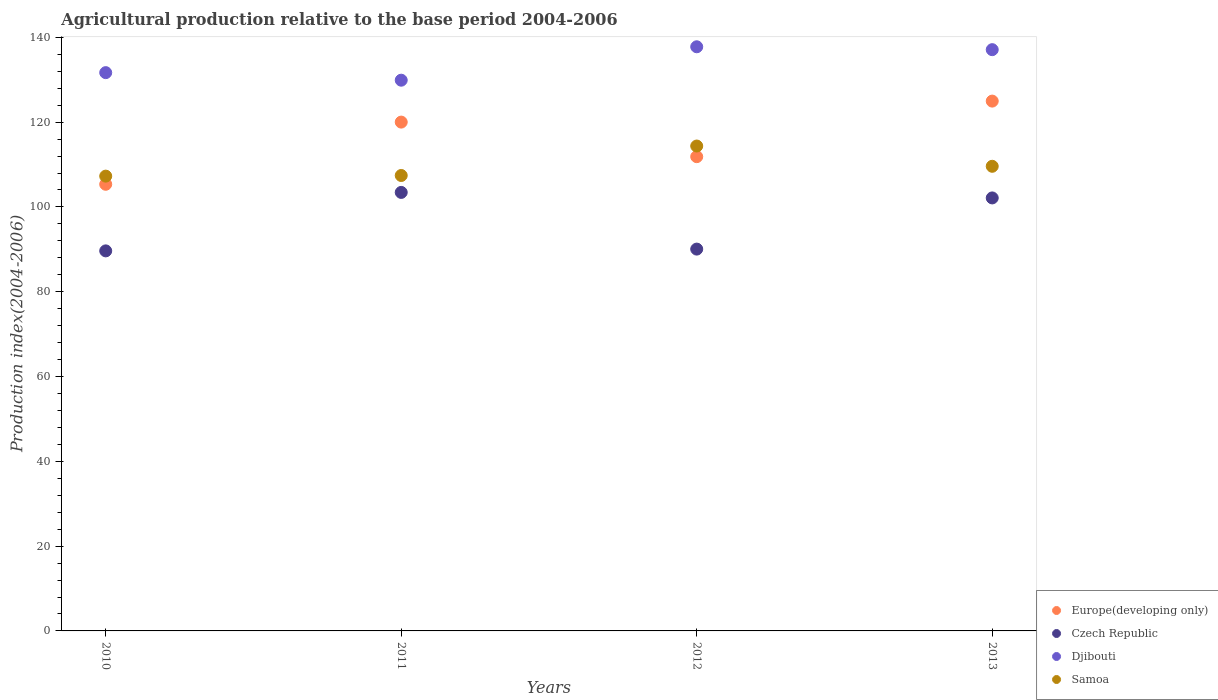Is the number of dotlines equal to the number of legend labels?
Your answer should be very brief. Yes. What is the agricultural production index in Samoa in 2011?
Provide a succinct answer. 107.42. Across all years, what is the maximum agricultural production index in Europe(developing only)?
Offer a very short reply. 124.97. Across all years, what is the minimum agricultural production index in Europe(developing only)?
Offer a terse response. 105.35. What is the total agricultural production index in Europe(developing only) in the graph?
Keep it short and to the point. 462.19. What is the difference between the agricultural production index in Djibouti in 2012 and that in 2013?
Your answer should be compact. 0.68. What is the difference between the agricultural production index in Djibouti in 2013 and the agricultural production index in Czech Republic in 2010?
Your response must be concise. 47.46. What is the average agricultural production index in Samoa per year?
Your answer should be very brief. 109.66. In the year 2012, what is the difference between the agricultural production index in Djibouti and agricultural production index in Europe(developing only)?
Make the answer very short. 25.92. In how many years, is the agricultural production index in Djibouti greater than 60?
Make the answer very short. 4. What is the ratio of the agricultural production index in Djibouti in 2010 to that in 2011?
Your answer should be very brief. 1.01. What is the difference between the highest and the second highest agricultural production index in Europe(developing only)?
Your answer should be compact. 4.95. What is the difference between the highest and the lowest agricultural production index in Samoa?
Offer a very short reply. 7.1. Is the agricultural production index in Czech Republic strictly greater than the agricultural production index in Djibouti over the years?
Provide a succinct answer. No. Is the agricultural production index in Samoa strictly less than the agricultural production index in Europe(developing only) over the years?
Your answer should be compact. No. What is the difference between two consecutive major ticks on the Y-axis?
Offer a terse response. 20. Are the values on the major ticks of Y-axis written in scientific E-notation?
Offer a very short reply. No. Does the graph contain any zero values?
Give a very brief answer. No. How many legend labels are there?
Provide a succinct answer. 4. What is the title of the graph?
Offer a terse response. Agricultural production relative to the base period 2004-2006. What is the label or title of the X-axis?
Give a very brief answer. Years. What is the label or title of the Y-axis?
Your response must be concise. Production index(2004-2006). What is the Production index(2004-2006) in Europe(developing only) in 2010?
Your answer should be very brief. 105.35. What is the Production index(2004-2006) in Czech Republic in 2010?
Make the answer very short. 89.64. What is the Production index(2004-2006) of Djibouti in 2010?
Make the answer very short. 131.68. What is the Production index(2004-2006) in Samoa in 2010?
Your answer should be compact. 107.27. What is the Production index(2004-2006) of Europe(developing only) in 2011?
Your response must be concise. 120.01. What is the Production index(2004-2006) of Czech Republic in 2011?
Your response must be concise. 103.43. What is the Production index(2004-2006) in Djibouti in 2011?
Provide a short and direct response. 129.9. What is the Production index(2004-2006) in Samoa in 2011?
Your answer should be compact. 107.42. What is the Production index(2004-2006) in Europe(developing only) in 2012?
Your answer should be very brief. 111.86. What is the Production index(2004-2006) of Czech Republic in 2012?
Offer a very short reply. 90.06. What is the Production index(2004-2006) in Djibouti in 2012?
Keep it short and to the point. 137.78. What is the Production index(2004-2006) in Samoa in 2012?
Keep it short and to the point. 114.37. What is the Production index(2004-2006) in Europe(developing only) in 2013?
Your response must be concise. 124.97. What is the Production index(2004-2006) in Czech Republic in 2013?
Your answer should be very brief. 102.13. What is the Production index(2004-2006) of Djibouti in 2013?
Offer a very short reply. 137.1. What is the Production index(2004-2006) in Samoa in 2013?
Provide a succinct answer. 109.59. Across all years, what is the maximum Production index(2004-2006) in Europe(developing only)?
Your answer should be compact. 124.97. Across all years, what is the maximum Production index(2004-2006) in Czech Republic?
Provide a succinct answer. 103.43. Across all years, what is the maximum Production index(2004-2006) of Djibouti?
Ensure brevity in your answer.  137.78. Across all years, what is the maximum Production index(2004-2006) of Samoa?
Ensure brevity in your answer.  114.37. Across all years, what is the minimum Production index(2004-2006) of Europe(developing only)?
Give a very brief answer. 105.35. Across all years, what is the minimum Production index(2004-2006) in Czech Republic?
Your answer should be very brief. 89.64. Across all years, what is the minimum Production index(2004-2006) of Djibouti?
Keep it short and to the point. 129.9. Across all years, what is the minimum Production index(2004-2006) of Samoa?
Provide a short and direct response. 107.27. What is the total Production index(2004-2006) in Europe(developing only) in the graph?
Ensure brevity in your answer.  462.19. What is the total Production index(2004-2006) in Czech Republic in the graph?
Your response must be concise. 385.26. What is the total Production index(2004-2006) in Djibouti in the graph?
Your response must be concise. 536.46. What is the total Production index(2004-2006) in Samoa in the graph?
Provide a succinct answer. 438.65. What is the difference between the Production index(2004-2006) in Europe(developing only) in 2010 and that in 2011?
Provide a short and direct response. -14.67. What is the difference between the Production index(2004-2006) of Czech Republic in 2010 and that in 2011?
Keep it short and to the point. -13.79. What is the difference between the Production index(2004-2006) in Djibouti in 2010 and that in 2011?
Your answer should be very brief. 1.78. What is the difference between the Production index(2004-2006) in Europe(developing only) in 2010 and that in 2012?
Your answer should be very brief. -6.51. What is the difference between the Production index(2004-2006) in Czech Republic in 2010 and that in 2012?
Your answer should be compact. -0.42. What is the difference between the Production index(2004-2006) in Samoa in 2010 and that in 2012?
Give a very brief answer. -7.1. What is the difference between the Production index(2004-2006) in Europe(developing only) in 2010 and that in 2013?
Make the answer very short. -19.62. What is the difference between the Production index(2004-2006) of Czech Republic in 2010 and that in 2013?
Your answer should be compact. -12.49. What is the difference between the Production index(2004-2006) in Djibouti in 2010 and that in 2013?
Ensure brevity in your answer.  -5.42. What is the difference between the Production index(2004-2006) of Samoa in 2010 and that in 2013?
Make the answer very short. -2.32. What is the difference between the Production index(2004-2006) in Europe(developing only) in 2011 and that in 2012?
Offer a terse response. 8.15. What is the difference between the Production index(2004-2006) in Czech Republic in 2011 and that in 2012?
Your answer should be very brief. 13.37. What is the difference between the Production index(2004-2006) in Djibouti in 2011 and that in 2012?
Make the answer very short. -7.88. What is the difference between the Production index(2004-2006) of Samoa in 2011 and that in 2012?
Offer a very short reply. -6.95. What is the difference between the Production index(2004-2006) in Europe(developing only) in 2011 and that in 2013?
Offer a terse response. -4.95. What is the difference between the Production index(2004-2006) in Samoa in 2011 and that in 2013?
Provide a succinct answer. -2.17. What is the difference between the Production index(2004-2006) in Europe(developing only) in 2012 and that in 2013?
Your answer should be compact. -13.1. What is the difference between the Production index(2004-2006) of Czech Republic in 2012 and that in 2013?
Provide a short and direct response. -12.07. What is the difference between the Production index(2004-2006) in Djibouti in 2012 and that in 2013?
Offer a terse response. 0.68. What is the difference between the Production index(2004-2006) of Samoa in 2012 and that in 2013?
Ensure brevity in your answer.  4.78. What is the difference between the Production index(2004-2006) of Europe(developing only) in 2010 and the Production index(2004-2006) of Czech Republic in 2011?
Your answer should be very brief. 1.92. What is the difference between the Production index(2004-2006) of Europe(developing only) in 2010 and the Production index(2004-2006) of Djibouti in 2011?
Your response must be concise. -24.55. What is the difference between the Production index(2004-2006) of Europe(developing only) in 2010 and the Production index(2004-2006) of Samoa in 2011?
Give a very brief answer. -2.07. What is the difference between the Production index(2004-2006) in Czech Republic in 2010 and the Production index(2004-2006) in Djibouti in 2011?
Keep it short and to the point. -40.26. What is the difference between the Production index(2004-2006) in Czech Republic in 2010 and the Production index(2004-2006) in Samoa in 2011?
Make the answer very short. -17.78. What is the difference between the Production index(2004-2006) of Djibouti in 2010 and the Production index(2004-2006) of Samoa in 2011?
Ensure brevity in your answer.  24.26. What is the difference between the Production index(2004-2006) of Europe(developing only) in 2010 and the Production index(2004-2006) of Czech Republic in 2012?
Your response must be concise. 15.29. What is the difference between the Production index(2004-2006) in Europe(developing only) in 2010 and the Production index(2004-2006) in Djibouti in 2012?
Give a very brief answer. -32.43. What is the difference between the Production index(2004-2006) in Europe(developing only) in 2010 and the Production index(2004-2006) in Samoa in 2012?
Offer a terse response. -9.02. What is the difference between the Production index(2004-2006) in Czech Republic in 2010 and the Production index(2004-2006) in Djibouti in 2012?
Offer a terse response. -48.14. What is the difference between the Production index(2004-2006) in Czech Republic in 2010 and the Production index(2004-2006) in Samoa in 2012?
Ensure brevity in your answer.  -24.73. What is the difference between the Production index(2004-2006) of Djibouti in 2010 and the Production index(2004-2006) of Samoa in 2012?
Your response must be concise. 17.31. What is the difference between the Production index(2004-2006) of Europe(developing only) in 2010 and the Production index(2004-2006) of Czech Republic in 2013?
Your answer should be compact. 3.22. What is the difference between the Production index(2004-2006) of Europe(developing only) in 2010 and the Production index(2004-2006) of Djibouti in 2013?
Offer a very short reply. -31.75. What is the difference between the Production index(2004-2006) in Europe(developing only) in 2010 and the Production index(2004-2006) in Samoa in 2013?
Make the answer very short. -4.24. What is the difference between the Production index(2004-2006) of Czech Republic in 2010 and the Production index(2004-2006) of Djibouti in 2013?
Ensure brevity in your answer.  -47.46. What is the difference between the Production index(2004-2006) of Czech Republic in 2010 and the Production index(2004-2006) of Samoa in 2013?
Ensure brevity in your answer.  -19.95. What is the difference between the Production index(2004-2006) in Djibouti in 2010 and the Production index(2004-2006) in Samoa in 2013?
Your response must be concise. 22.09. What is the difference between the Production index(2004-2006) in Europe(developing only) in 2011 and the Production index(2004-2006) in Czech Republic in 2012?
Your answer should be very brief. 29.95. What is the difference between the Production index(2004-2006) of Europe(developing only) in 2011 and the Production index(2004-2006) of Djibouti in 2012?
Your response must be concise. -17.77. What is the difference between the Production index(2004-2006) of Europe(developing only) in 2011 and the Production index(2004-2006) of Samoa in 2012?
Make the answer very short. 5.64. What is the difference between the Production index(2004-2006) in Czech Republic in 2011 and the Production index(2004-2006) in Djibouti in 2012?
Ensure brevity in your answer.  -34.35. What is the difference between the Production index(2004-2006) in Czech Republic in 2011 and the Production index(2004-2006) in Samoa in 2012?
Your response must be concise. -10.94. What is the difference between the Production index(2004-2006) of Djibouti in 2011 and the Production index(2004-2006) of Samoa in 2012?
Ensure brevity in your answer.  15.53. What is the difference between the Production index(2004-2006) of Europe(developing only) in 2011 and the Production index(2004-2006) of Czech Republic in 2013?
Make the answer very short. 17.88. What is the difference between the Production index(2004-2006) in Europe(developing only) in 2011 and the Production index(2004-2006) in Djibouti in 2013?
Provide a succinct answer. -17.09. What is the difference between the Production index(2004-2006) of Europe(developing only) in 2011 and the Production index(2004-2006) of Samoa in 2013?
Provide a succinct answer. 10.42. What is the difference between the Production index(2004-2006) of Czech Republic in 2011 and the Production index(2004-2006) of Djibouti in 2013?
Provide a succinct answer. -33.67. What is the difference between the Production index(2004-2006) in Czech Republic in 2011 and the Production index(2004-2006) in Samoa in 2013?
Make the answer very short. -6.16. What is the difference between the Production index(2004-2006) of Djibouti in 2011 and the Production index(2004-2006) of Samoa in 2013?
Make the answer very short. 20.31. What is the difference between the Production index(2004-2006) of Europe(developing only) in 2012 and the Production index(2004-2006) of Czech Republic in 2013?
Your answer should be compact. 9.73. What is the difference between the Production index(2004-2006) in Europe(developing only) in 2012 and the Production index(2004-2006) in Djibouti in 2013?
Your response must be concise. -25.24. What is the difference between the Production index(2004-2006) in Europe(developing only) in 2012 and the Production index(2004-2006) in Samoa in 2013?
Ensure brevity in your answer.  2.27. What is the difference between the Production index(2004-2006) of Czech Republic in 2012 and the Production index(2004-2006) of Djibouti in 2013?
Keep it short and to the point. -47.04. What is the difference between the Production index(2004-2006) of Czech Republic in 2012 and the Production index(2004-2006) of Samoa in 2013?
Provide a short and direct response. -19.53. What is the difference between the Production index(2004-2006) in Djibouti in 2012 and the Production index(2004-2006) in Samoa in 2013?
Your answer should be very brief. 28.19. What is the average Production index(2004-2006) of Europe(developing only) per year?
Make the answer very short. 115.55. What is the average Production index(2004-2006) in Czech Republic per year?
Keep it short and to the point. 96.31. What is the average Production index(2004-2006) in Djibouti per year?
Give a very brief answer. 134.12. What is the average Production index(2004-2006) of Samoa per year?
Your answer should be very brief. 109.66. In the year 2010, what is the difference between the Production index(2004-2006) in Europe(developing only) and Production index(2004-2006) in Czech Republic?
Your response must be concise. 15.71. In the year 2010, what is the difference between the Production index(2004-2006) of Europe(developing only) and Production index(2004-2006) of Djibouti?
Your answer should be very brief. -26.33. In the year 2010, what is the difference between the Production index(2004-2006) of Europe(developing only) and Production index(2004-2006) of Samoa?
Your answer should be compact. -1.92. In the year 2010, what is the difference between the Production index(2004-2006) of Czech Republic and Production index(2004-2006) of Djibouti?
Your answer should be very brief. -42.04. In the year 2010, what is the difference between the Production index(2004-2006) in Czech Republic and Production index(2004-2006) in Samoa?
Provide a succinct answer. -17.63. In the year 2010, what is the difference between the Production index(2004-2006) of Djibouti and Production index(2004-2006) of Samoa?
Offer a terse response. 24.41. In the year 2011, what is the difference between the Production index(2004-2006) in Europe(developing only) and Production index(2004-2006) in Czech Republic?
Your response must be concise. 16.58. In the year 2011, what is the difference between the Production index(2004-2006) in Europe(developing only) and Production index(2004-2006) in Djibouti?
Provide a succinct answer. -9.89. In the year 2011, what is the difference between the Production index(2004-2006) in Europe(developing only) and Production index(2004-2006) in Samoa?
Your answer should be compact. 12.59. In the year 2011, what is the difference between the Production index(2004-2006) of Czech Republic and Production index(2004-2006) of Djibouti?
Ensure brevity in your answer.  -26.47. In the year 2011, what is the difference between the Production index(2004-2006) in Czech Republic and Production index(2004-2006) in Samoa?
Provide a succinct answer. -3.99. In the year 2011, what is the difference between the Production index(2004-2006) of Djibouti and Production index(2004-2006) of Samoa?
Provide a succinct answer. 22.48. In the year 2012, what is the difference between the Production index(2004-2006) in Europe(developing only) and Production index(2004-2006) in Czech Republic?
Ensure brevity in your answer.  21.8. In the year 2012, what is the difference between the Production index(2004-2006) of Europe(developing only) and Production index(2004-2006) of Djibouti?
Make the answer very short. -25.92. In the year 2012, what is the difference between the Production index(2004-2006) of Europe(developing only) and Production index(2004-2006) of Samoa?
Your answer should be very brief. -2.51. In the year 2012, what is the difference between the Production index(2004-2006) in Czech Republic and Production index(2004-2006) in Djibouti?
Provide a succinct answer. -47.72. In the year 2012, what is the difference between the Production index(2004-2006) of Czech Republic and Production index(2004-2006) of Samoa?
Offer a terse response. -24.31. In the year 2012, what is the difference between the Production index(2004-2006) in Djibouti and Production index(2004-2006) in Samoa?
Your answer should be very brief. 23.41. In the year 2013, what is the difference between the Production index(2004-2006) in Europe(developing only) and Production index(2004-2006) in Czech Republic?
Your response must be concise. 22.84. In the year 2013, what is the difference between the Production index(2004-2006) in Europe(developing only) and Production index(2004-2006) in Djibouti?
Keep it short and to the point. -12.13. In the year 2013, what is the difference between the Production index(2004-2006) of Europe(developing only) and Production index(2004-2006) of Samoa?
Offer a very short reply. 15.38. In the year 2013, what is the difference between the Production index(2004-2006) in Czech Republic and Production index(2004-2006) in Djibouti?
Ensure brevity in your answer.  -34.97. In the year 2013, what is the difference between the Production index(2004-2006) in Czech Republic and Production index(2004-2006) in Samoa?
Keep it short and to the point. -7.46. In the year 2013, what is the difference between the Production index(2004-2006) of Djibouti and Production index(2004-2006) of Samoa?
Offer a very short reply. 27.51. What is the ratio of the Production index(2004-2006) in Europe(developing only) in 2010 to that in 2011?
Provide a succinct answer. 0.88. What is the ratio of the Production index(2004-2006) in Czech Republic in 2010 to that in 2011?
Your answer should be very brief. 0.87. What is the ratio of the Production index(2004-2006) of Djibouti in 2010 to that in 2011?
Provide a short and direct response. 1.01. What is the ratio of the Production index(2004-2006) of Europe(developing only) in 2010 to that in 2012?
Give a very brief answer. 0.94. What is the ratio of the Production index(2004-2006) of Djibouti in 2010 to that in 2012?
Ensure brevity in your answer.  0.96. What is the ratio of the Production index(2004-2006) of Samoa in 2010 to that in 2012?
Make the answer very short. 0.94. What is the ratio of the Production index(2004-2006) in Europe(developing only) in 2010 to that in 2013?
Offer a very short reply. 0.84. What is the ratio of the Production index(2004-2006) of Czech Republic in 2010 to that in 2013?
Your answer should be compact. 0.88. What is the ratio of the Production index(2004-2006) in Djibouti in 2010 to that in 2013?
Give a very brief answer. 0.96. What is the ratio of the Production index(2004-2006) of Samoa in 2010 to that in 2013?
Give a very brief answer. 0.98. What is the ratio of the Production index(2004-2006) of Europe(developing only) in 2011 to that in 2012?
Provide a short and direct response. 1.07. What is the ratio of the Production index(2004-2006) in Czech Republic in 2011 to that in 2012?
Ensure brevity in your answer.  1.15. What is the ratio of the Production index(2004-2006) in Djibouti in 2011 to that in 2012?
Your response must be concise. 0.94. What is the ratio of the Production index(2004-2006) in Samoa in 2011 to that in 2012?
Keep it short and to the point. 0.94. What is the ratio of the Production index(2004-2006) of Europe(developing only) in 2011 to that in 2013?
Your answer should be compact. 0.96. What is the ratio of the Production index(2004-2006) in Czech Republic in 2011 to that in 2013?
Offer a very short reply. 1.01. What is the ratio of the Production index(2004-2006) in Djibouti in 2011 to that in 2013?
Keep it short and to the point. 0.95. What is the ratio of the Production index(2004-2006) in Samoa in 2011 to that in 2013?
Your answer should be very brief. 0.98. What is the ratio of the Production index(2004-2006) in Europe(developing only) in 2012 to that in 2013?
Provide a succinct answer. 0.9. What is the ratio of the Production index(2004-2006) of Czech Republic in 2012 to that in 2013?
Offer a terse response. 0.88. What is the ratio of the Production index(2004-2006) in Djibouti in 2012 to that in 2013?
Offer a terse response. 1. What is the ratio of the Production index(2004-2006) in Samoa in 2012 to that in 2013?
Make the answer very short. 1.04. What is the difference between the highest and the second highest Production index(2004-2006) in Europe(developing only)?
Your answer should be very brief. 4.95. What is the difference between the highest and the second highest Production index(2004-2006) of Czech Republic?
Your answer should be very brief. 1.3. What is the difference between the highest and the second highest Production index(2004-2006) of Djibouti?
Make the answer very short. 0.68. What is the difference between the highest and the second highest Production index(2004-2006) in Samoa?
Offer a very short reply. 4.78. What is the difference between the highest and the lowest Production index(2004-2006) in Europe(developing only)?
Offer a very short reply. 19.62. What is the difference between the highest and the lowest Production index(2004-2006) of Czech Republic?
Ensure brevity in your answer.  13.79. What is the difference between the highest and the lowest Production index(2004-2006) in Djibouti?
Offer a terse response. 7.88. What is the difference between the highest and the lowest Production index(2004-2006) of Samoa?
Offer a terse response. 7.1. 